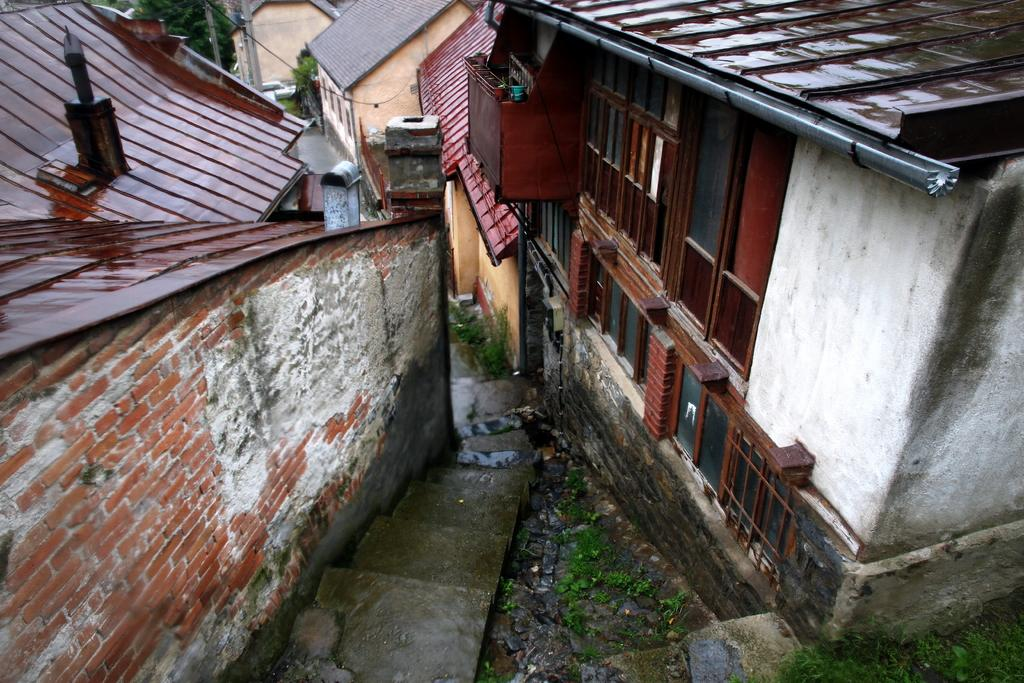What type of structures can be seen in the image? There are houses in the image. What architectural feature is present in the image? There is a staircase in the image. What type of vegetation is visible in the image? There are trees and plants in the image. What is the ground covered with in the image? There is green grass in the image. What are the poles used for in the image? The purpose of the poles is not specified, but they are present in the image. What type of material is present on the ground in the image? There are stones in the image. What objects can be seen on the surface in the image? There are objects on the surface in the image, but their specific nature is not mentioned. What type of sweater is the person wearing while teaching in the image? There is no person wearing a sweater or teaching in the image; it features houses, a staircase, trees, plants, green grass, poles, stones, and objects on the surface. How many balloons are tied to the trees in the image? There are no balloons present in the image; it features houses, a staircase, trees, plants, green grass, poles, stones, and objects on the surface. 